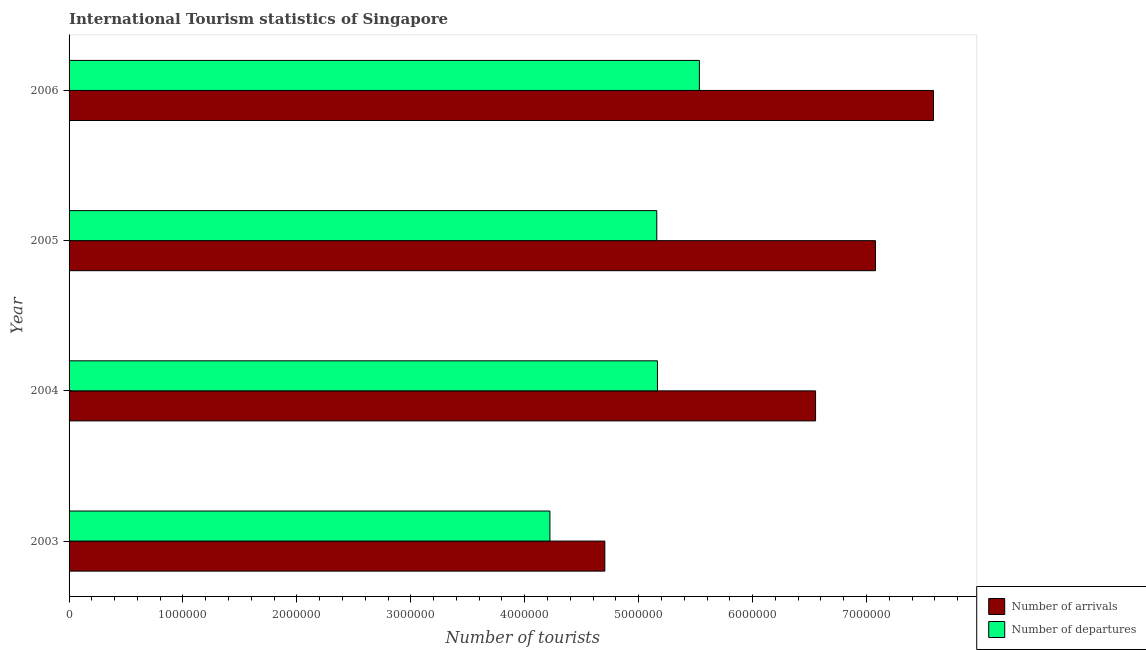How many different coloured bars are there?
Keep it short and to the point. 2. Are the number of bars per tick equal to the number of legend labels?
Provide a succinct answer. Yes. Are the number of bars on each tick of the Y-axis equal?
Provide a succinct answer. Yes. What is the label of the 2nd group of bars from the top?
Your answer should be very brief. 2005. In how many cases, is the number of bars for a given year not equal to the number of legend labels?
Offer a terse response. 0. What is the number of tourist arrivals in 2006?
Make the answer very short. 7.59e+06. Across all years, what is the maximum number of tourist arrivals?
Ensure brevity in your answer.  7.59e+06. Across all years, what is the minimum number of tourist arrivals?
Offer a terse response. 4.70e+06. In which year was the number of tourist arrivals minimum?
Offer a very short reply. 2003. What is the total number of tourist arrivals in the graph?
Your answer should be compact. 2.59e+07. What is the difference between the number of tourist departures in 2003 and that in 2005?
Your answer should be compact. -9.38e+05. What is the difference between the number of tourist departures in 2006 and the number of tourist arrivals in 2004?
Your response must be concise. -1.02e+06. What is the average number of tourist arrivals per year?
Offer a very short reply. 6.48e+06. In the year 2006, what is the difference between the number of tourist arrivals and number of tourist departures?
Make the answer very short. 2.06e+06. What is the ratio of the number of tourist departures in 2004 to that in 2005?
Your answer should be compact. 1. What is the difference between the highest and the second highest number of tourist departures?
Your response must be concise. 3.68e+05. What is the difference between the highest and the lowest number of tourist departures?
Your answer should be very brief. 1.31e+06. In how many years, is the number of tourist arrivals greater than the average number of tourist arrivals taken over all years?
Ensure brevity in your answer.  3. What does the 1st bar from the top in 2004 represents?
Keep it short and to the point. Number of departures. What does the 1st bar from the bottom in 2006 represents?
Offer a very short reply. Number of arrivals. How many bars are there?
Make the answer very short. 8. Are all the bars in the graph horizontal?
Make the answer very short. Yes. What is the difference between two consecutive major ticks on the X-axis?
Your answer should be compact. 1.00e+06. Are the values on the major ticks of X-axis written in scientific E-notation?
Make the answer very short. No. Does the graph contain any zero values?
Your answer should be very brief. No. Does the graph contain grids?
Offer a very short reply. No. Where does the legend appear in the graph?
Offer a very short reply. Bottom right. How are the legend labels stacked?
Your answer should be compact. Vertical. What is the title of the graph?
Provide a succinct answer. International Tourism statistics of Singapore. What is the label or title of the X-axis?
Ensure brevity in your answer.  Number of tourists. What is the Number of tourists of Number of arrivals in 2003?
Provide a short and direct response. 4.70e+06. What is the Number of tourists in Number of departures in 2003?
Make the answer very short. 4.22e+06. What is the Number of tourists in Number of arrivals in 2004?
Provide a succinct answer. 6.55e+06. What is the Number of tourists of Number of departures in 2004?
Offer a terse response. 5.16e+06. What is the Number of tourists of Number of arrivals in 2005?
Make the answer very short. 7.08e+06. What is the Number of tourists in Number of departures in 2005?
Offer a terse response. 5.16e+06. What is the Number of tourists of Number of arrivals in 2006?
Keep it short and to the point. 7.59e+06. What is the Number of tourists of Number of departures in 2006?
Provide a short and direct response. 5.53e+06. Across all years, what is the maximum Number of tourists in Number of arrivals?
Your response must be concise. 7.59e+06. Across all years, what is the maximum Number of tourists in Number of departures?
Provide a short and direct response. 5.53e+06. Across all years, what is the minimum Number of tourists in Number of arrivals?
Ensure brevity in your answer.  4.70e+06. Across all years, what is the minimum Number of tourists in Number of departures?
Ensure brevity in your answer.  4.22e+06. What is the total Number of tourists of Number of arrivals in the graph?
Offer a terse response. 2.59e+07. What is the total Number of tourists in Number of departures in the graph?
Your response must be concise. 2.01e+07. What is the difference between the Number of tourists of Number of arrivals in 2003 and that in 2004?
Your answer should be very brief. -1.85e+06. What is the difference between the Number of tourists of Number of departures in 2003 and that in 2004?
Ensure brevity in your answer.  -9.44e+05. What is the difference between the Number of tourists of Number of arrivals in 2003 and that in 2005?
Make the answer very short. -2.38e+06. What is the difference between the Number of tourists in Number of departures in 2003 and that in 2005?
Provide a short and direct response. -9.38e+05. What is the difference between the Number of tourists in Number of arrivals in 2003 and that in 2006?
Give a very brief answer. -2.88e+06. What is the difference between the Number of tourists of Number of departures in 2003 and that in 2006?
Offer a very short reply. -1.31e+06. What is the difference between the Number of tourists of Number of arrivals in 2004 and that in 2005?
Ensure brevity in your answer.  -5.26e+05. What is the difference between the Number of tourists of Number of departures in 2004 and that in 2005?
Ensure brevity in your answer.  6000. What is the difference between the Number of tourists of Number of arrivals in 2004 and that in 2006?
Your answer should be compact. -1.04e+06. What is the difference between the Number of tourists in Number of departures in 2004 and that in 2006?
Your answer should be very brief. -3.68e+05. What is the difference between the Number of tourists in Number of arrivals in 2005 and that in 2006?
Offer a terse response. -5.09e+05. What is the difference between the Number of tourists of Number of departures in 2005 and that in 2006?
Ensure brevity in your answer.  -3.74e+05. What is the difference between the Number of tourists of Number of arrivals in 2003 and the Number of tourists of Number of departures in 2004?
Keep it short and to the point. -4.62e+05. What is the difference between the Number of tourists in Number of arrivals in 2003 and the Number of tourists in Number of departures in 2005?
Offer a terse response. -4.56e+05. What is the difference between the Number of tourists of Number of arrivals in 2003 and the Number of tourists of Number of departures in 2006?
Provide a short and direct response. -8.30e+05. What is the difference between the Number of tourists in Number of arrivals in 2004 and the Number of tourists in Number of departures in 2005?
Keep it short and to the point. 1.39e+06. What is the difference between the Number of tourists of Number of arrivals in 2004 and the Number of tourists of Number of departures in 2006?
Provide a succinct answer. 1.02e+06. What is the difference between the Number of tourists of Number of arrivals in 2005 and the Number of tourists of Number of departures in 2006?
Provide a short and direct response. 1.55e+06. What is the average Number of tourists in Number of arrivals per year?
Ensure brevity in your answer.  6.48e+06. What is the average Number of tourists in Number of departures per year?
Offer a terse response. 5.02e+06. In the year 2003, what is the difference between the Number of tourists of Number of arrivals and Number of tourists of Number of departures?
Your answer should be very brief. 4.82e+05. In the year 2004, what is the difference between the Number of tourists of Number of arrivals and Number of tourists of Number of departures?
Offer a very short reply. 1.39e+06. In the year 2005, what is the difference between the Number of tourists in Number of arrivals and Number of tourists in Number of departures?
Make the answer very short. 1.92e+06. In the year 2006, what is the difference between the Number of tourists in Number of arrivals and Number of tourists in Number of departures?
Your answer should be very brief. 2.06e+06. What is the ratio of the Number of tourists of Number of arrivals in 2003 to that in 2004?
Provide a succinct answer. 0.72. What is the ratio of the Number of tourists of Number of departures in 2003 to that in 2004?
Provide a short and direct response. 0.82. What is the ratio of the Number of tourists in Number of arrivals in 2003 to that in 2005?
Provide a short and direct response. 0.66. What is the ratio of the Number of tourists of Number of departures in 2003 to that in 2005?
Keep it short and to the point. 0.82. What is the ratio of the Number of tourists in Number of arrivals in 2003 to that in 2006?
Provide a short and direct response. 0.62. What is the ratio of the Number of tourists in Number of departures in 2003 to that in 2006?
Keep it short and to the point. 0.76. What is the ratio of the Number of tourists in Number of arrivals in 2004 to that in 2005?
Keep it short and to the point. 0.93. What is the ratio of the Number of tourists in Number of arrivals in 2004 to that in 2006?
Offer a very short reply. 0.86. What is the ratio of the Number of tourists in Number of departures in 2004 to that in 2006?
Ensure brevity in your answer.  0.93. What is the ratio of the Number of tourists of Number of arrivals in 2005 to that in 2006?
Offer a terse response. 0.93. What is the ratio of the Number of tourists in Number of departures in 2005 to that in 2006?
Offer a very short reply. 0.93. What is the difference between the highest and the second highest Number of tourists of Number of arrivals?
Make the answer very short. 5.09e+05. What is the difference between the highest and the second highest Number of tourists of Number of departures?
Your answer should be very brief. 3.68e+05. What is the difference between the highest and the lowest Number of tourists of Number of arrivals?
Provide a succinct answer. 2.88e+06. What is the difference between the highest and the lowest Number of tourists in Number of departures?
Provide a short and direct response. 1.31e+06. 